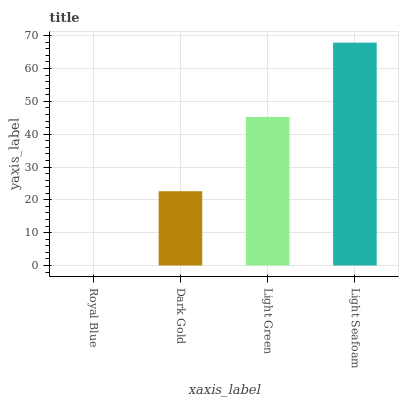Is Royal Blue the minimum?
Answer yes or no. Yes. Is Light Seafoam the maximum?
Answer yes or no. Yes. Is Dark Gold the minimum?
Answer yes or no. No. Is Dark Gold the maximum?
Answer yes or no. No. Is Dark Gold greater than Royal Blue?
Answer yes or no. Yes. Is Royal Blue less than Dark Gold?
Answer yes or no. Yes. Is Royal Blue greater than Dark Gold?
Answer yes or no. No. Is Dark Gold less than Royal Blue?
Answer yes or no. No. Is Light Green the high median?
Answer yes or no. Yes. Is Dark Gold the low median?
Answer yes or no. Yes. Is Royal Blue the high median?
Answer yes or no. No. Is Royal Blue the low median?
Answer yes or no. No. 